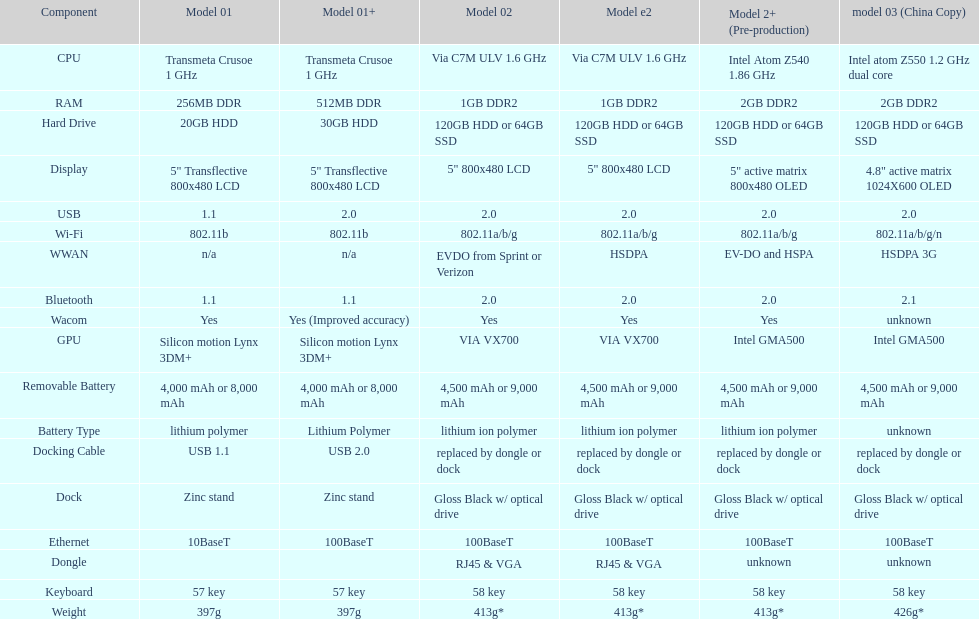Parse the full table. {'header': ['Component', 'Model 01', 'Model 01+', 'Model 02', 'Model e2', 'Model 2+ (Pre-production)', 'model 03 (China Copy)'], 'rows': [['CPU', 'Transmeta Crusoe 1\xa0GHz', 'Transmeta Crusoe 1\xa0GHz', 'Via C7M ULV 1.6\xa0GHz', 'Via C7M ULV 1.6\xa0GHz', 'Intel Atom Z540 1.86\xa0GHz', 'Intel atom Z550 1.2\xa0GHz dual core'], ['RAM', '256MB DDR', '512MB DDR', '1GB DDR2', '1GB DDR2', '2GB DDR2', '2GB DDR2'], ['Hard Drive', '20GB HDD', '30GB HDD', '120GB HDD or 64GB SSD', '120GB HDD or 64GB SSD', '120GB HDD or 64GB SSD', '120GB HDD or 64GB SSD'], ['Display', '5" Transflective 800x480 LCD', '5" Transflective 800x480 LCD', '5" 800x480 LCD', '5" 800x480 LCD', '5" active matrix 800x480 OLED', '4.8" active matrix 1024X600 OLED'], ['USB', '1.1', '2.0', '2.0', '2.0', '2.0', '2.0'], ['Wi-Fi', '802.11b', '802.11b', '802.11a/b/g', '802.11a/b/g', '802.11a/b/g', '802.11a/b/g/n'], ['WWAN', 'n/a', 'n/a', 'EVDO from Sprint or Verizon', 'HSDPA', 'EV-DO and HSPA', 'HSDPA 3G'], ['Bluetooth', '1.1', '1.1', '2.0', '2.0', '2.0', '2.1'], ['Wacom', 'Yes', 'Yes (Improved accuracy)', 'Yes', 'Yes', 'Yes', 'unknown'], ['GPU', 'Silicon motion Lynx 3DM+', 'Silicon motion Lynx 3DM+', 'VIA VX700', 'VIA VX700', 'Intel GMA500', 'Intel GMA500'], ['Removable Battery', '4,000 mAh or 8,000 mAh', '4,000 mAh or 8,000 mAh', '4,500 mAh or 9,000 mAh', '4,500 mAh or 9,000 mAh', '4,500 mAh or 9,000 mAh', '4,500 mAh or 9,000 mAh'], ['Battery Type', 'lithium polymer', 'Lithium Polymer', 'lithium ion polymer', 'lithium ion polymer', 'lithium ion polymer', 'unknown'], ['Docking Cable', 'USB 1.1', 'USB 2.0', 'replaced by dongle or dock', 'replaced by dongle or dock', 'replaced by dongle or dock', 'replaced by dongle or dock'], ['Dock', 'Zinc stand', 'Zinc stand', 'Gloss Black w/ optical drive', 'Gloss Black w/ optical drive', 'Gloss Black w/ optical drive', 'Gloss Black w/ optical drive'], ['Ethernet', '10BaseT', '100BaseT', '100BaseT', '100BaseT', '100BaseT', '100BaseT'], ['Dongle', '', '', 'RJ45 & VGA', 'RJ45 & VGA', 'unknown', 'unknown'], ['Keyboard', '57 key', '57 key', '58 key', '58 key', '58 key', '58 key'], ['Weight', '397g', '397g', '413g*', '413g*', '413g*', '426g*']]} Can one identify a minimum of 13 distinct elements on the graph? Yes. 